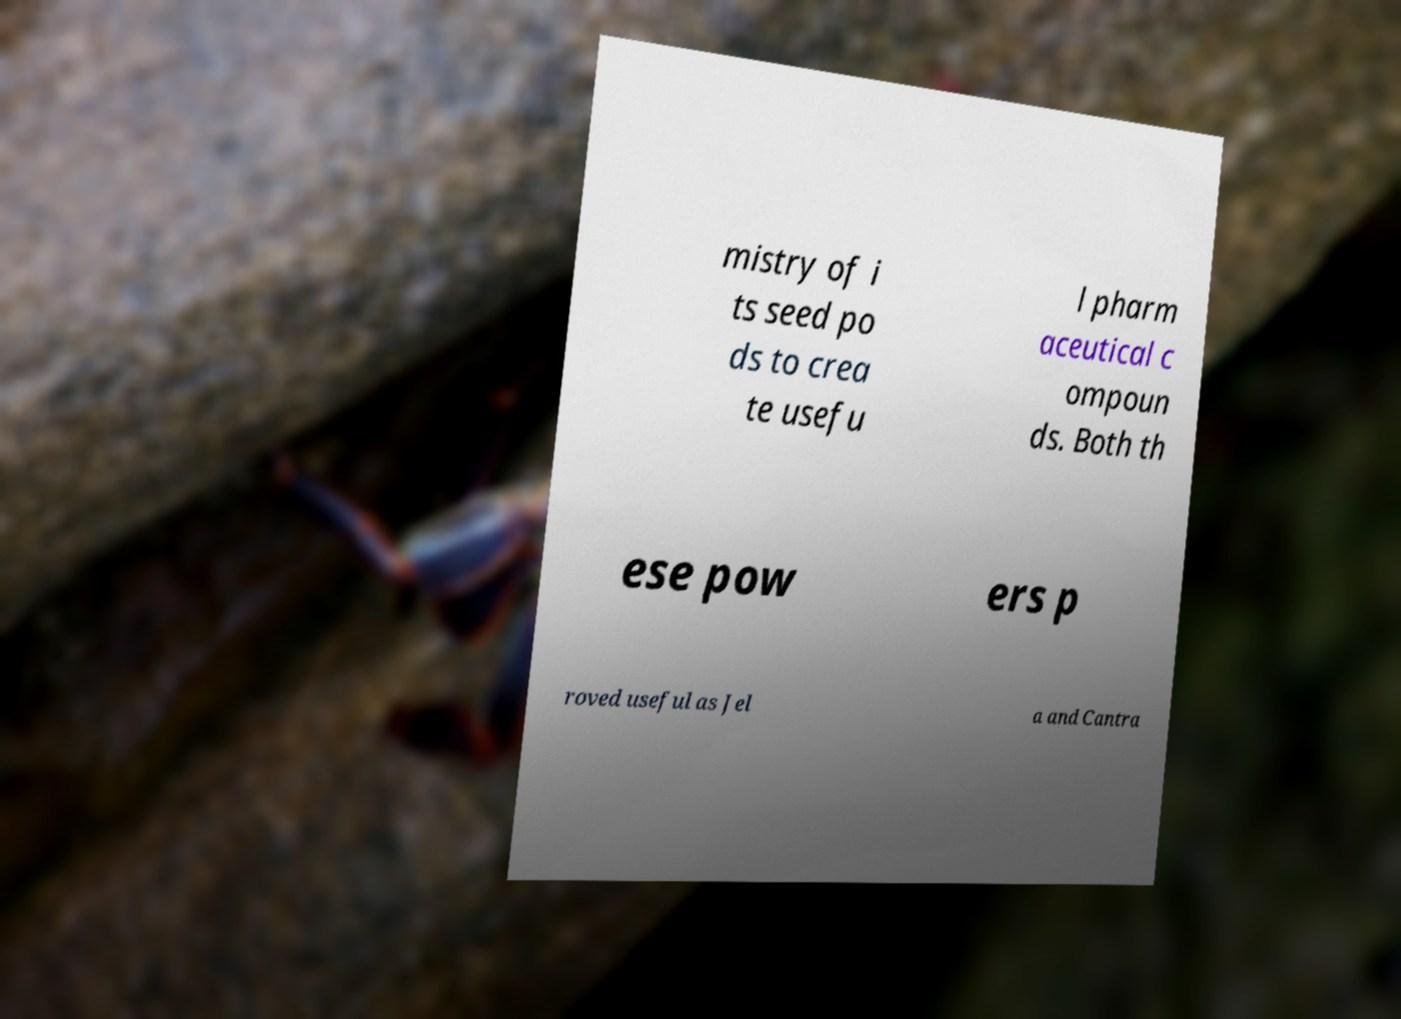Please read and relay the text visible in this image. What does it say? mistry of i ts seed po ds to crea te usefu l pharm aceutical c ompoun ds. Both th ese pow ers p roved useful as Jel a and Cantra 